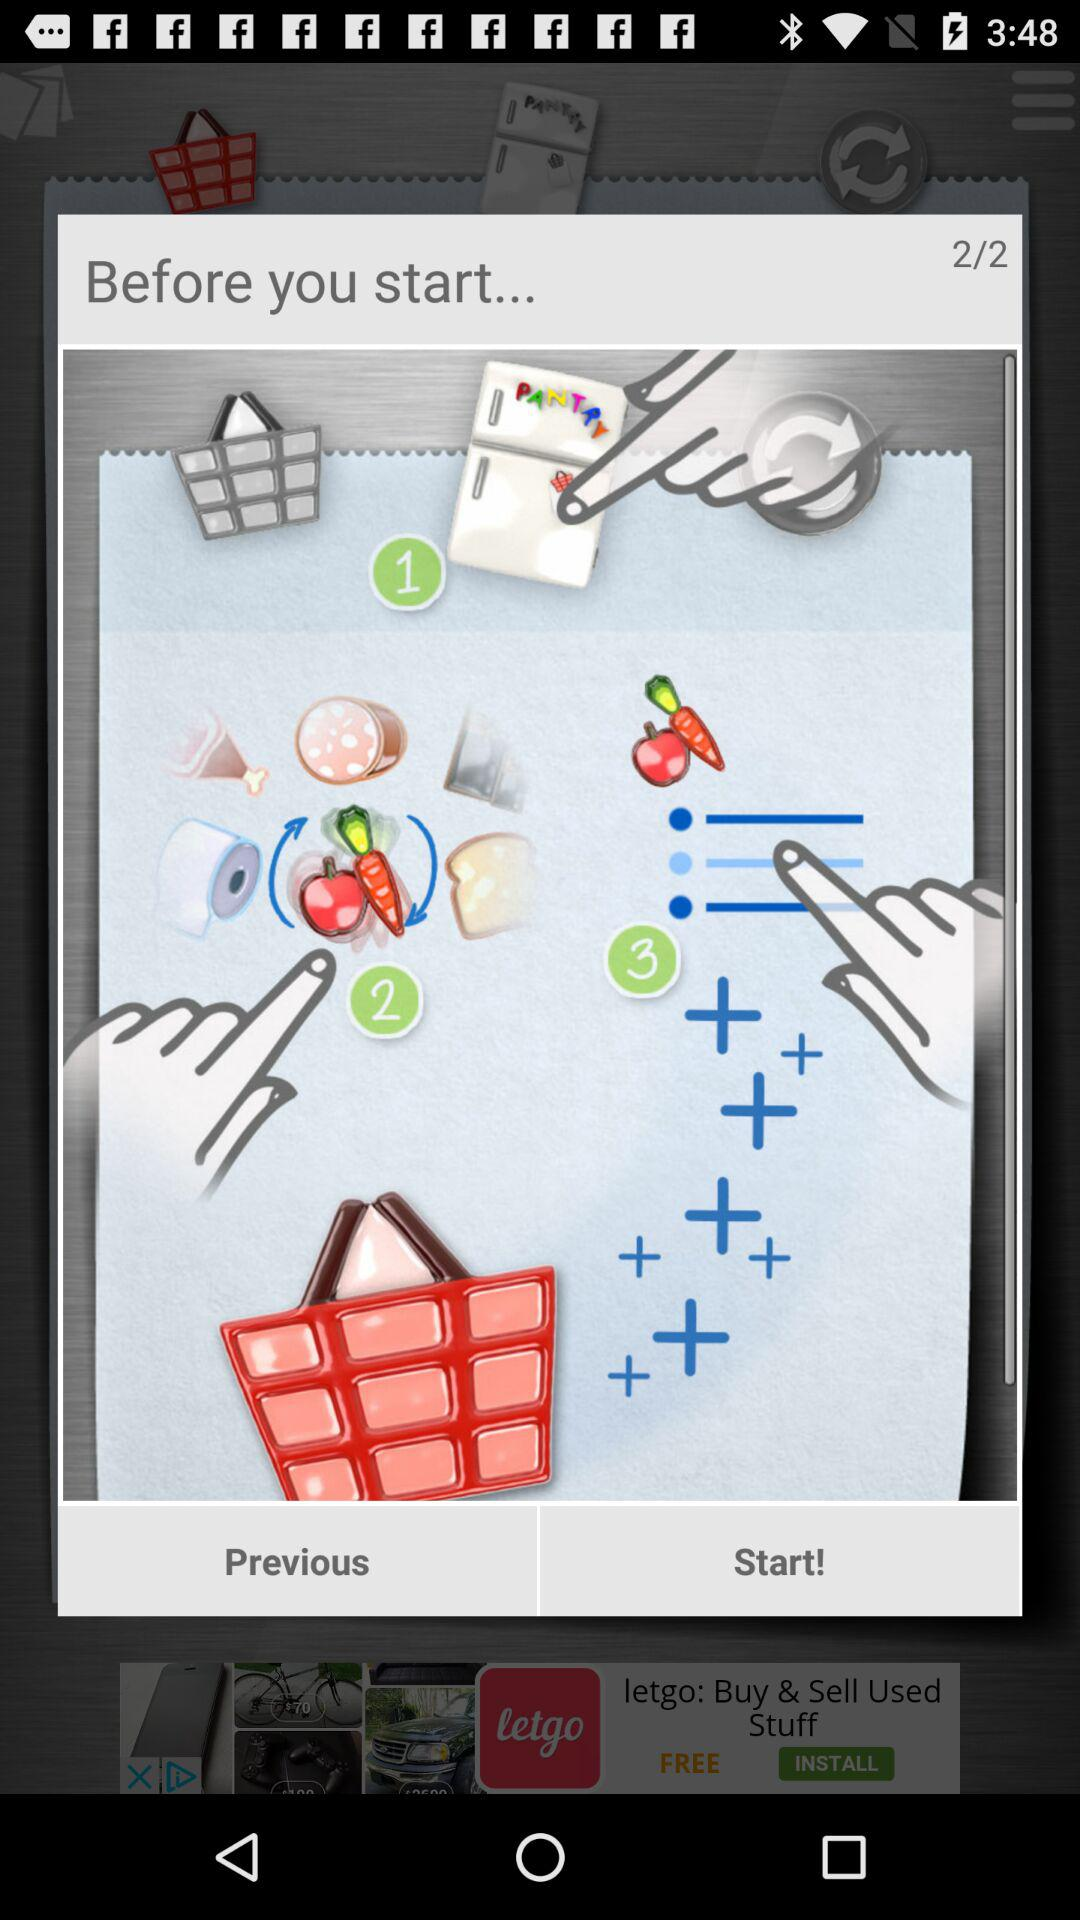Which page is the person currently on? The person is currently on the second page. 